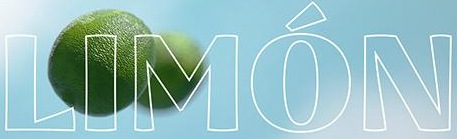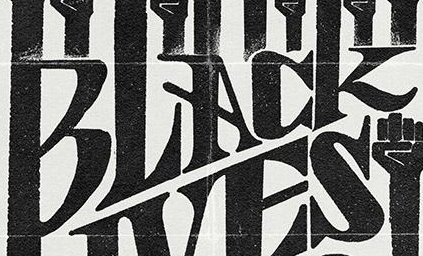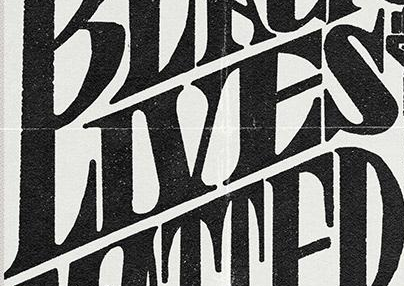What words can you see in these images in sequence, separated by a semicolon? LIMÓN; BLACK; LIVES 